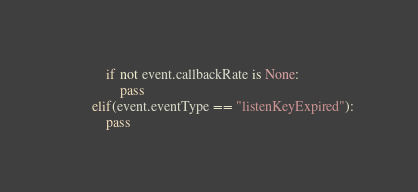<code> <loc_0><loc_0><loc_500><loc_500><_Python_>            if not event.callbackRate is None:
                pass
        elif(event.eventType == "listenKeyExpired"):
            pass


</code> 